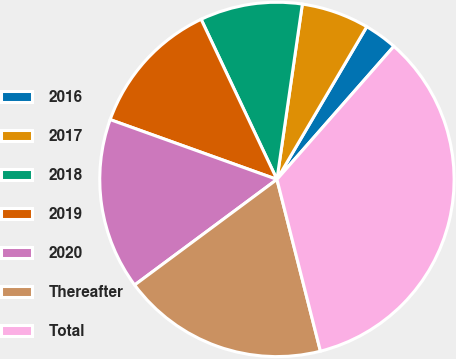Convert chart to OTSL. <chart><loc_0><loc_0><loc_500><loc_500><pie_chart><fcel>2016<fcel>2017<fcel>2018<fcel>2019<fcel>2020<fcel>Thereafter<fcel>Total<nl><fcel>3.01%<fcel>6.17%<fcel>9.33%<fcel>12.48%<fcel>15.64%<fcel>18.79%<fcel>34.58%<nl></chart> 